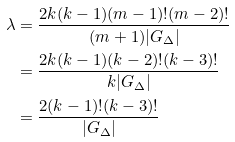Convert formula to latex. <formula><loc_0><loc_0><loc_500><loc_500>\lambda & = \frac { 2 k ( k - 1 ) ( m - 1 ) ! ( m - 2 ) ! } { ( m + 1 ) | G _ { \Delta } | } \\ & = \frac { 2 k ( k - 1 ) ( k - 2 ) ! ( k - 3 ) ! } { k | G _ { \Delta } | } \\ & = \frac { 2 ( k - 1 ) ! ( k - 3 ) ! } { | G _ { \Delta } | }</formula> 